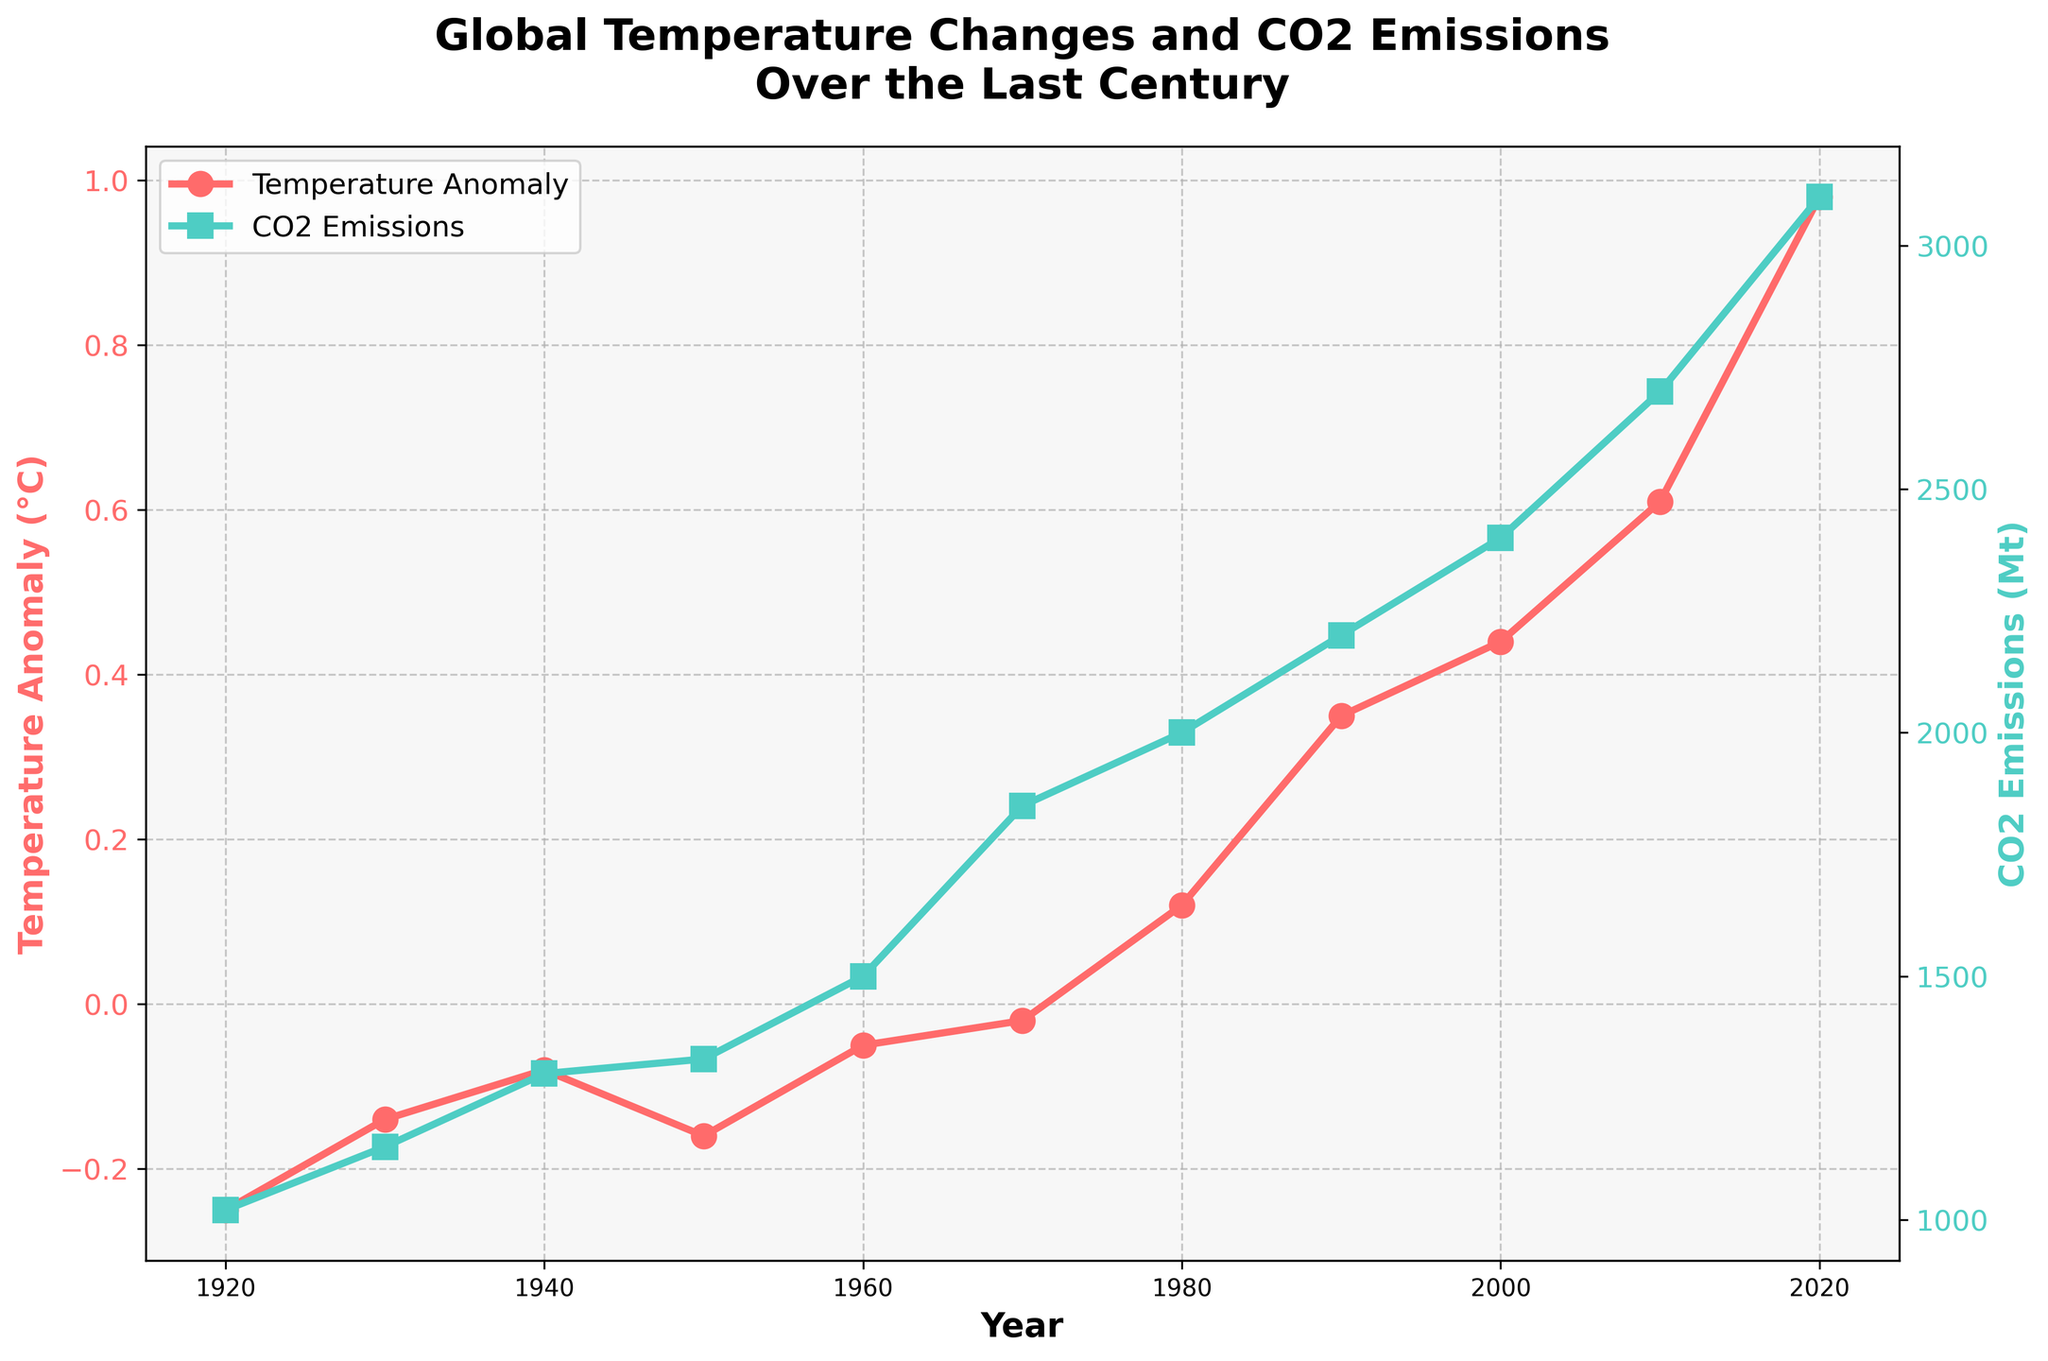What's the title of the plot? The title is clearly marked at the top of the plot, above all the data points and labels. It reads "Global Temperature Changes and CO2 Emissions Over the Last Century".
Answer: Global Temperature Changes and CO2 Emissions Over the Last Century What are the two variables shown in the plot? The plot clearly labels two axes: one for "Temperature Anomaly (°C)" on the left side and one for "CO2 Emissions (Mt)" on the right side. These variables represent global temperature anomalies and CO2 emissions, respectively.
Answer: Global Temperature Anomaly (°C) and CO2 Emissions (Mt) What color represents the CO2 emissions on the plot? The plot uses a dual-axis system where CO2 emissions are represented by a green-colored line and square markers. This is specifically highlighted in the legend and the right y-axis label.
Answer: Green During which decade did CO2 emissions see the most significant increase? Looking at the plot, the increase in CO2 emissions appears steepest between 2000 and 2010. In 2000, CO2 emissions were at 2400 Mt, and by 2010, they had increased to 2700 Mt, a significant rise.
Answer: 2000-2010 What was the global temperature anomaly in the year 1980? According to the plot, the temperature anomaly for 1980 is marked with a red circle on the left y-axis. The corresponding value reads 0.12°C.
Answer: 0.12°C How does the trend of global temperature anomaly correlate with CO2 emissions over the century? The overall trend shows that as CO2 emissions have increased, the global temperature anomaly has also risen. Both lines show an upward trajectory, indicating a positive correlation between CO2 emissions and global temperature anomalies.
Answer: Positive correlation Which year had the highest temperature anomaly, and what was its value? The plot indicates that the year 2020 had the highest temperature anomaly. The corresponding red circle on the temperature anomaly line reads 0.98°C.
Answer: 2020, 0.98°C What were the CO2 emissions in 1950, and how did they change by 2020? CO2 emissions in 1950 were marked by a green square at 1330 Mt. By 2020, they had increased to 3100 Mt. This can be calculated by subtracting the 1950 value from the 2020 value, giving us a change of 3100 - 1330 = 1770 Mt.
Answer: 1770 Mt increase Which variable had more significant visual amplification over the decades, temperature anomaly or CO2 emissions? By examining the scales, CO2 emissions show more significant increases numerically (1020 Mt in 1920 to 3100 Mt in 2020) compared to the temperature anomaly changes (-0.25°C in 1920 to 0.98°C in 2020), indicating CO2 emissions have a more prominent visual amplification.
Answer: CO2 Emissions What was the approximate difference in temperature anomaly between 1920 and 2020? The temperature anomaly in 1920 was -0.25°C, and in 2020 it was 0.98°C. Calculating the difference, we get 0.98 - (-0.25) = 1.23°C.
Answer: 1.23°C 